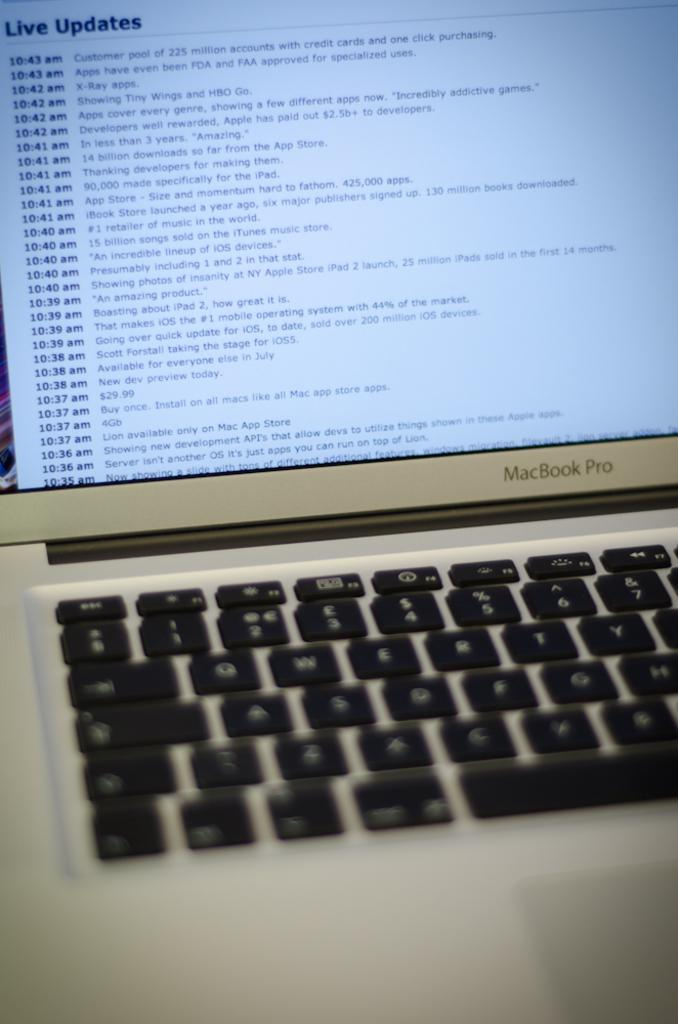<image>
Offer a succinct explanation of the picture presented. The screen shows updates from different times including 10.35 to 10.43. 